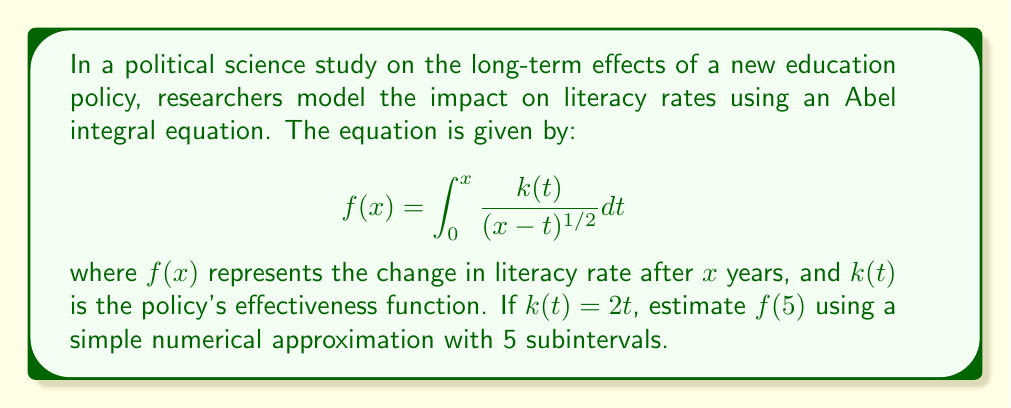Can you answer this question? To estimate $f(5)$ using a simple numerical approximation with 5 subintervals, we'll follow these steps:

1) Divide the interval $[0,5]$ into 5 equal subintervals, each of width $\Delta t = 1$.

2) Use the midpoint of each subinterval for $t$:
   $t_1 = 0.5, t_2 = 1.5, t_3 = 2.5, t_4 = 3.5, t_5 = 4.5$

3) Calculate $k(t)$ for each midpoint:
   $k(0.5) = 1, k(1.5) = 3, k(2.5) = 5, k(3.5) = 7, k(4.5) = 9$

4) Calculate $(5-t)^{-1/2}$ for each midpoint:
   $(5-0.5)^{-1/2} = 0.4714, (5-1.5)^{-1/2} = 0.5774, (5-2.5)^{-1/2} = 0.7071$
   $(5-3.5)^{-1/2} = 0.9129, (5-4.5)^{-1/2} = 1.4142$

5) Multiply $k(t)$ and $(5-t)^{-1/2}$ for each subinterval:
   $1 \cdot 0.4714 = 0.4714, 3 \cdot 0.5774 = 1.7322, 5 \cdot 0.7071 = 3.5355$
   $7 \cdot 0.9129 = 6.3903, 9 \cdot 1.4142 = 12.7278$

6) Sum these products and multiply by $\Delta t$:
   $f(5) \approx 1 \cdot (0.4714 + 1.7322 + 3.5355 + 6.3903 + 12.7278) = 24.8572$

Thus, our estimate for $f(5)$ is approximately 24.8572.
Answer: $f(5) \approx 24.8572$ 